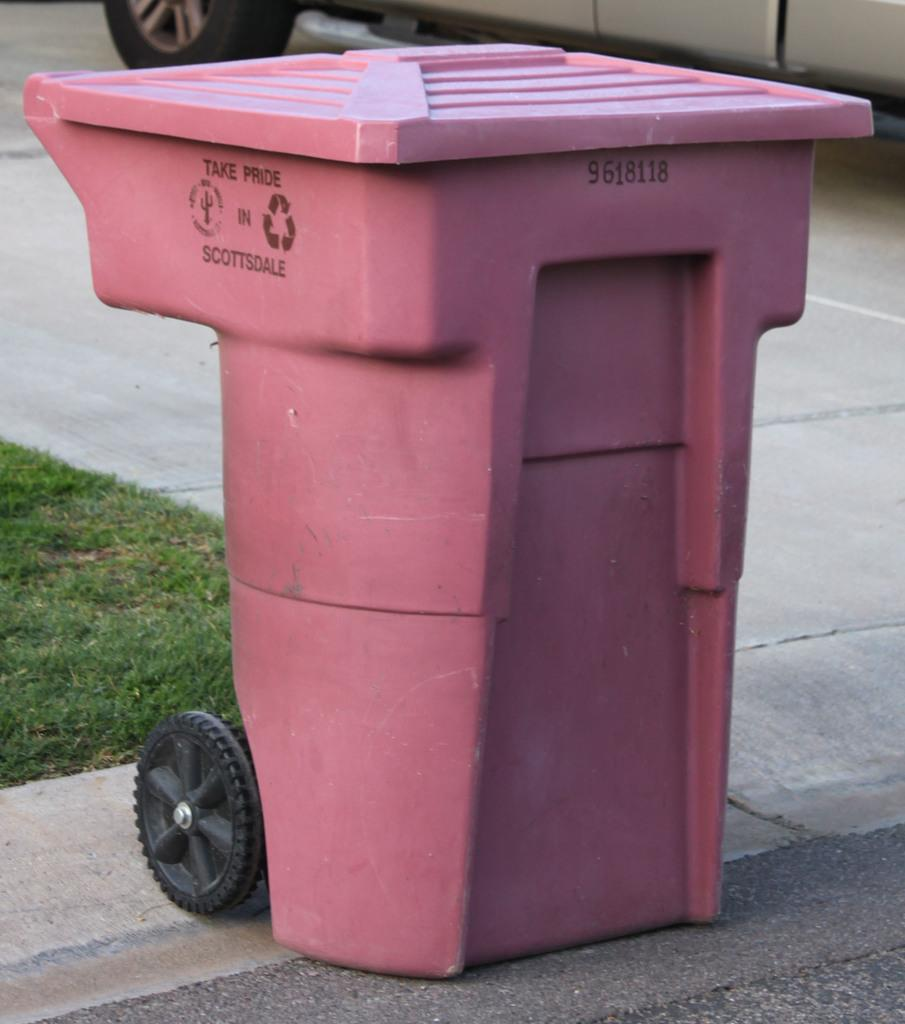<image>
Relay a brief, clear account of the picture shown. A pink recycling can at the curb for pickup. 